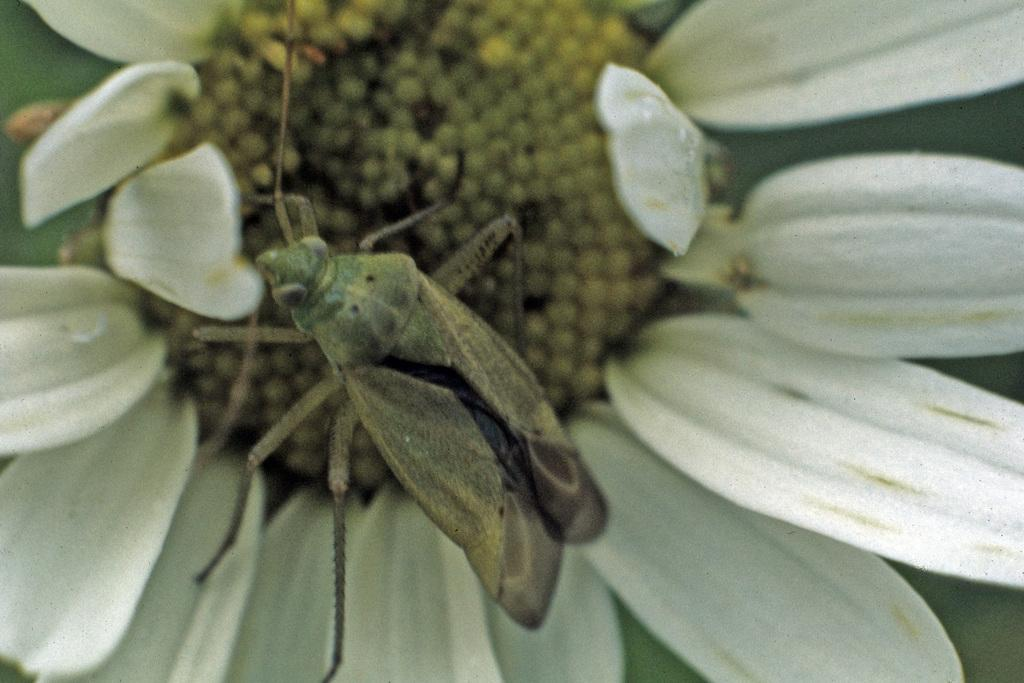What is present in the image? There is an insect in the image. Where is the insect located? The insect is on a flower. What type of roof can be seen on the goat in the image? There is no goat or roof present in the image; it features an insect on a flower. How many coils are visible on the insect in the image? The insect in the image does not have coils; it is a single, solid organism. 